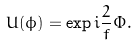Convert formula to latex. <formula><loc_0><loc_0><loc_500><loc_500>U ( \phi ) = \exp i \frac { 2 } { f } \Phi .</formula> 